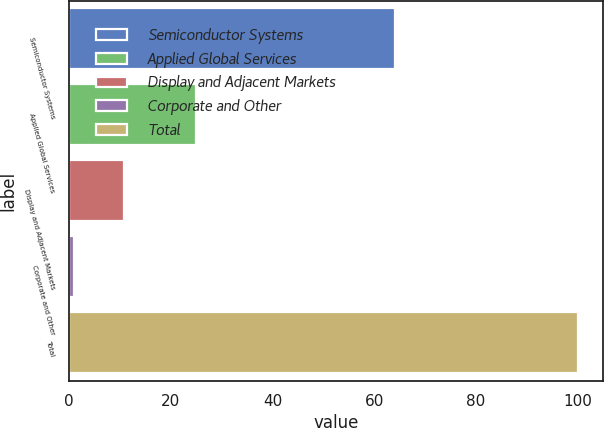Convert chart to OTSL. <chart><loc_0><loc_0><loc_500><loc_500><bar_chart><fcel>Semiconductor Systems<fcel>Applied Global Services<fcel>Display and Adjacent Markets<fcel>Corporate and Other<fcel>Total<nl><fcel>64<fcel>25<fcel>10.9<fcel>1<fcel>100<nl></chart> 